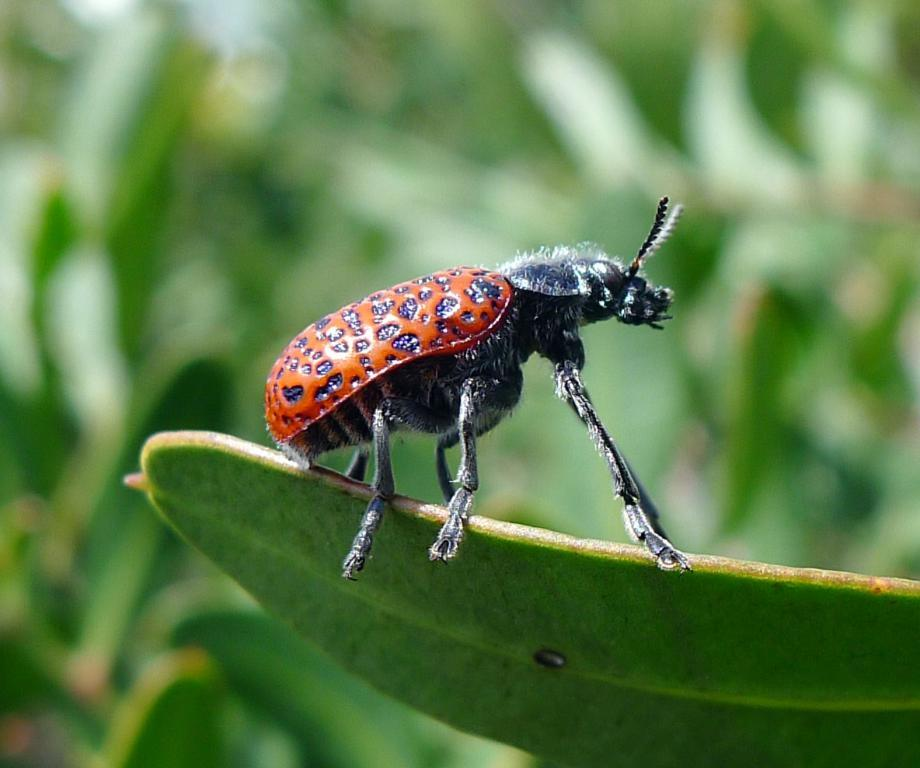What is the main subject of the image? There is an insect on a leaf in the image. How would you describe the background of the image? The background of the image is blurred. What type of environment can be seen in the background? There is greenery visible in the background of the image. What type of invention is being used by the insect in the image? There is no invention being used by the insect in the image; it is simply on a leaf. How many toothbrushes can be seen in the image? There are no toothbrushes present in the image. 